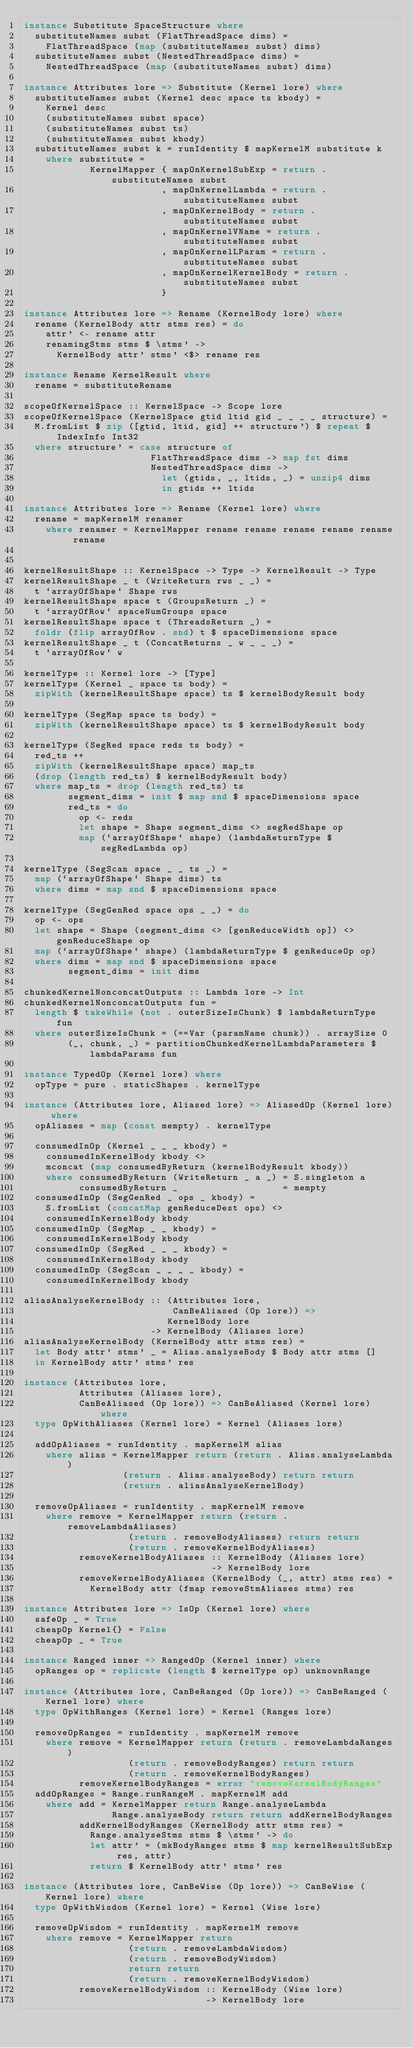<code> <loc_0><loc_0><loc_500><loc_500><_Haskell_>instance Substitute SpaceStructure where
  substituteNames subst (FlatThreadSpace dims) =
    FlatThreadSpace (map (substituteNames subst) dims)
  substituteNames subst (NestedThreadSpace dims) =
    NestedThreadSpace (map (substituteNames subst) dims)

instance Attributes lore => Substitute (Kernel lore) where
  substituteNames subst (Kernel desc space ts kbody) =
    Kernel desc
    (substituteNames subst space)
    (substituteNames subst ts)
    (substituteNames subst kbody)
  substituteNames subst k = runIdentity $ mapKernelM substitute k
    where substitute =
            KernelMapper { mapOnKernelSubExp = return . substituteNames subst
                         , mapOnKernelLambda = return . substituteNames subst
                         , mapOnKernelBody = return . substituteNames subst
                         , mapOnKernelVName = return . substituteNames subst
                         , mapOnKernelLParam = return . substituteNames subst
                         , mapOnKernelKernelBody = return . substituteNames subst
                         }

instance Attributes lore => Rename (KernelBody lore) where
  rename (KernelBody attr stms res) = do
    attr' <- rename attr
    renamingStms stms $ \stms' ->
      KernelBody attr' stms' <$> rename res

instance Rename KernelResult where
  rename = substituteRename

scopeOfKernelSpace :: KernelSpace -> Scope lore
scopeOfKernelSpace (KernelSpace gtid ltid gid _ _ _ _ structure) =
  M.fromList $ zip ([gtid, ltid, gid] ++ structure') $ repeat $ IndexInfo Int32
  where structure' = case structure of
                       FlatThreadSpace dims -> map fst dims
                       NestedThreadSpace dims ->
                         let (gtids, _, ltids, _) = unzip4 dims
                         in gtids ++ ltids

instance Attributes lore => Rename (Kernel lore) where
  rename = mapKernelM renamer
    where renamer = KernelMapper rename rename rename rename rename rename


kernelResultShape :: KernelSpace -> Type -> KernelResult -> Type
kernelResultShape _ t (WriteReturn rws _ _) =
  t `arrayOfShape` Shape rws
kernelResultShape space t (GroupsReturn _) =
  t `arrayOfRow` spaceNumGroups space
kernelResultShape space t (ThreadsReturn _) =
  foldr (flip arrayOfRow . snd) t $ spaceDimensions space
kernelResultShape _ t (ConcatReturns _ w _ _ _) =
  t `arrayOfRow` w

kernelType :: Kernel lore -> [Type]
kernelType (Kernel _ space ts body) =
  zipWith (kernelResultShape space) ts $ kernelBodyResult body

kernelType (SegMap space ts body) =
  zipWith (kernelResultShape space) ts $ kernelBodyResult body

kernelType (SegRed space reds ts body) =
  red_ts ++
  zipWith (kernelResultShape space) map_ts
  (drop (length red_ts) $ kernelBodyResult body)
  where map_ts = drop (length red_ts) ts
        segment_dims = init $ map snd $ spaceDimensions space
        red_ts = do
          op <- reds
          let shape = Shape segment_dims <> segRedShape op
          map (`arrayOfShape` shape) (lambdaReturnType $ segRedLambda op)

kernelType (SegScan space _ _ ts _) =
  map (`arrayOfShape` Shape dims) ts
  where dims = map snd $ spaceDimensions space

kernelType (SegGenRed space ops _ _) = do
  op <- ops
  let shape = Shape (segment_dims <> [genReduceWidth op]) <> genReduceShape op
  map (`arrayOfShape` shape) (lambdaReturnType $ genReduceOp op)
  where dims = map snd $ spaceDimensions space
        segment_dims = init dims

chunkedKernelNonconcatOutputs :: Lambda lore -> Int
chunkedKernelNonconcatOutputs fun =
  length $ takeWhile (not . outerSizeIsChunk) $ lambdaReturnType fun
  where outerSizeIsChunk = (==Var (paramName chunk)) . arraySize 0
        (_, chunk, _) = partitionChunkedKernelLambdaParameters $ lambdaParams fun

instance TypedOp (Kernel lore) where
  opType = pure . staticShapes . kernelType

instance (Attributes lore, Aliased lore) => AliasedOp (Kernel lore) where
  opAliases = map (const mempty) . kernelType

  consumedInOp (Kernel _ _ _ kbody) =
    consumedInKernelBody kbody <>
    mconcat (map consumedByReturn (kernelBodyResult kbody))
    where consumedByReturn (WriteReturn _ a _) = S.singleton a
          consumedByReturn _                   = mempty
  consumedInOp (SegGenRed _ ops _ kbody) =
    S.fromList (concatMap genReduceDest ops) <>
    consumedInKernelBody kbody
  consumedInOp (SegMap _ _ kbody) =
    consumedInKernelBody kbody
  consumedInOp (SegRed _ _ _ kbody) =
    consumedInKernelBody kbody
  consumedInOp (SegScan _ _ _ _ kbody) =
    consumedInKernelBody kbody

aliasAnalyseKernelBody :: (Attributes lore,
                           CanBeAliased (Op lore)) =>
                          KernelBody lore
                       -> KernelBody (Aliases lore)
aliasAnalyseKernelBody (KernelBody attr stms res) =
  let Body attr' stms' _ = Alias.analyseBody $ Body attr stms []
  in KernelBody attr' stms' res

instance (Attributes lore,
          Attributes (Aliases lore),
          CanBeAliased (Op lore)) => CanBeAliased (Kernel lore) where
  type OpWithAliases (Kernel lore) = Kernel (Aliases lore)

  addOpAliases = runIdentity . mapKernelM alias
    where alias = KernelMapper return (return . Alias.analyseLambda)
                  (return . Alias.analyseBody) return return
                  (return . aliasAnalyseKernelBody)

  removeOpAliases = runIdentity . mapKernelM remove
    where remove = KernelMapper return (return . removeLambdaAliases)
                   (return . removeBodyAliases) return return
                   (return . removeKernelBodyAliases)
          removeKernelBodyAliases :: KernelBody (Aliases lore)
                                  -> KernelBody lore
          removeKernelBodyAliases (KernelBody (_, attr) stms res) =
            KernelBody attr (fmap removeStmAliases stms) res

instance Attributes lore => IsOp (Kernel lore) where
  safeOp _ = True
  cheapOp Kernel{} = False
  cheapOp _ = True

instance Ranged inner => RangedOp (Kernel inner) where
  opRanges op = replicate (length $ kernelType op) unknownRange

instance (Attributes lore, CanBeRanged (Op lore)) => CanBeRanged (Kernel lore) where
  type OpWithRanges (Kernel lore) = Kernel (Ranges lore)

  removeOpRanges = runIdentity . mapKernelM remove
    where remove = KernelMapper return (return . removeLambdaRanges)
                   (return . removeBodyRanges) return return
                   (return . removeKernelBodyRanges)
          removeKernelBodyRanges = error "removeKernelBodyRanges"
  addOpRanges = Range.runRangeM . mapKernelM add
    where add = KernelMapper return Range.analyseLambda
                Range.analyseBody return return addKernelBodyRanges
          addKernelBodyRanges (KernelBody attr stms res) =
            Range.analyseStms stms $ \stms' -> do
            let attr' = (mkBodyRanges stms $ map kernelResultSubExp res, attr)
            return $ KernelBody attr' stms' res

instance (Attributes lore, CanBeWise (Op lore)) => CanBeWise (Kernel lore) where
  type OpWithWisdom (Kernel lore) = Kernel (Wise lore)

  removeOpWisdom = runIdentity . mapKernelM remove
    where remove = KernelMapper return
                   (return . removeLambdaWisdom)
                   (return . removeBodyWisdom)
                   return return
                   (return . removeKernelBodyWisdom)
          removeKernelBodyWisdom :: KernelBody (Wise lore)
                                 -> KernelBody lore</code> 